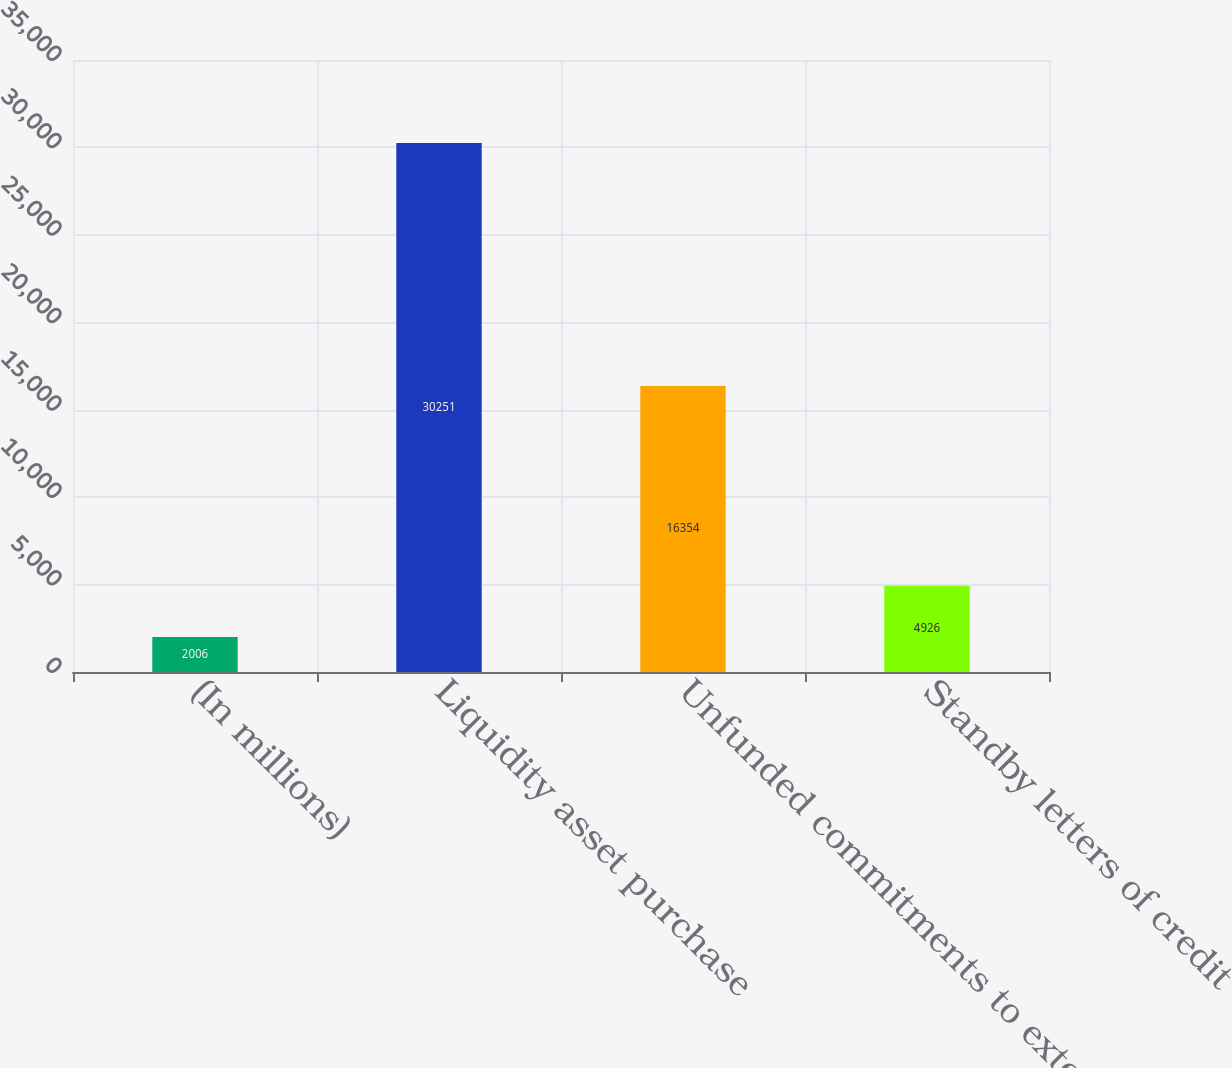<chart> <loc_0><loc_0><loc_500><loc_500><bar_chart><fcel>(In millions)<fcel>Liquidity asset purchase<fcel>Unfunded commitments to extend<fcel>Standby letters of credit<nl><fcel>2006<fcel>30251<fcel>16354<fcel>4926<nl></chart> 